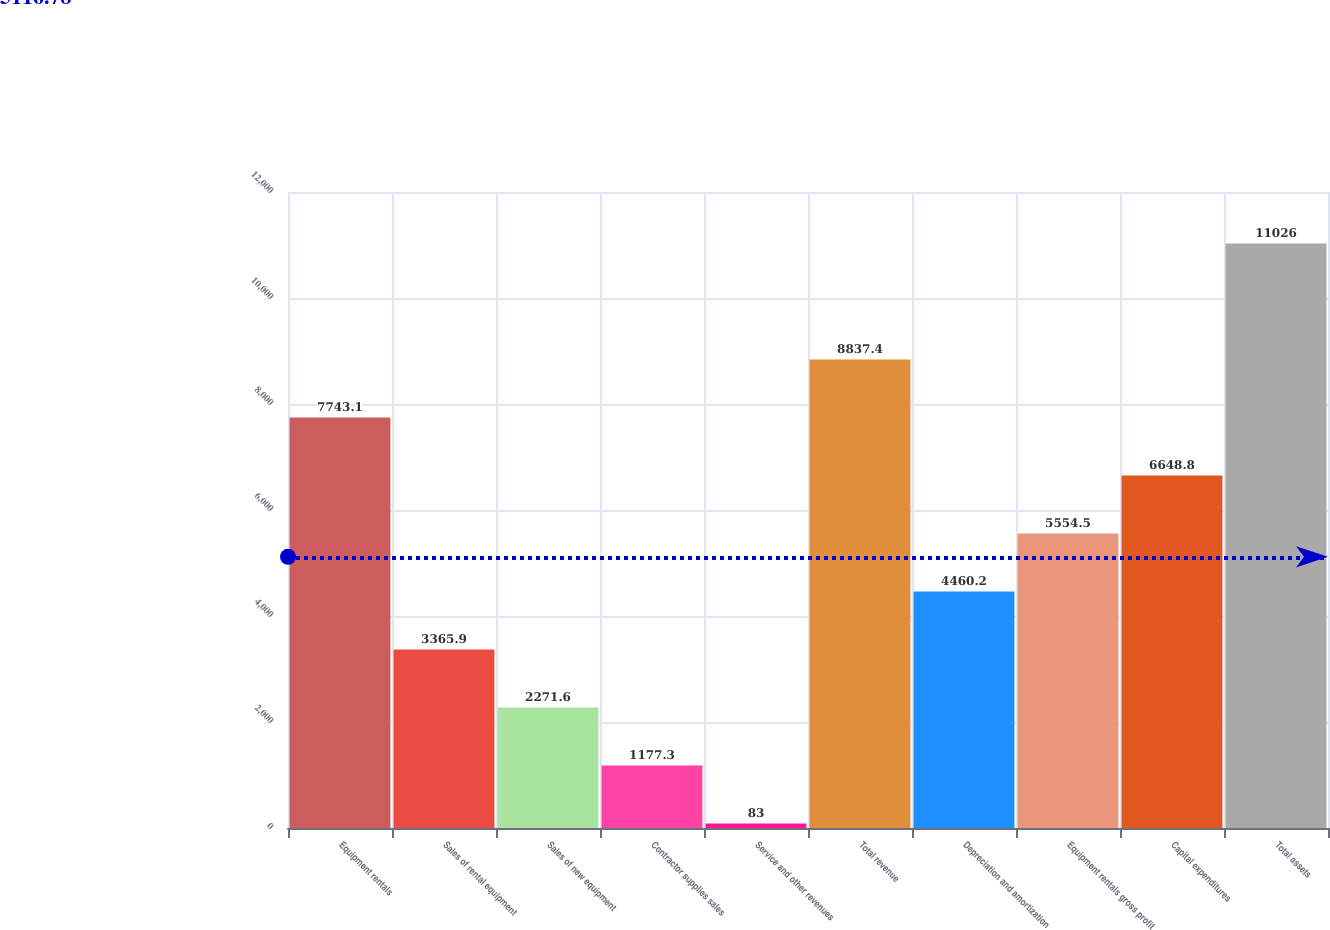<chart> <loc_0><loc_0><loc_500><loc_500><bar_chart><fcel>Equipment rentals<fcel>Sales of rental equipment<fcel>Sales of new equipment<fcel>Contractor supplies sales<fcel>Service and other revenues<fcel>Total revenue<fcel>Depreciation and amortization<fcel>Equipment rentals gross profit<fcel>Capital expenditures<fcel>Total assets<nl><fcel>7743.1<fcel>3365.9<fcel>2271.6<fcel>1177.3<fcel>83<fcel>8837.4<fcel>4460.2<fcel>5554.5<fcel>6648.8<fcel>11026<nl></chart> 